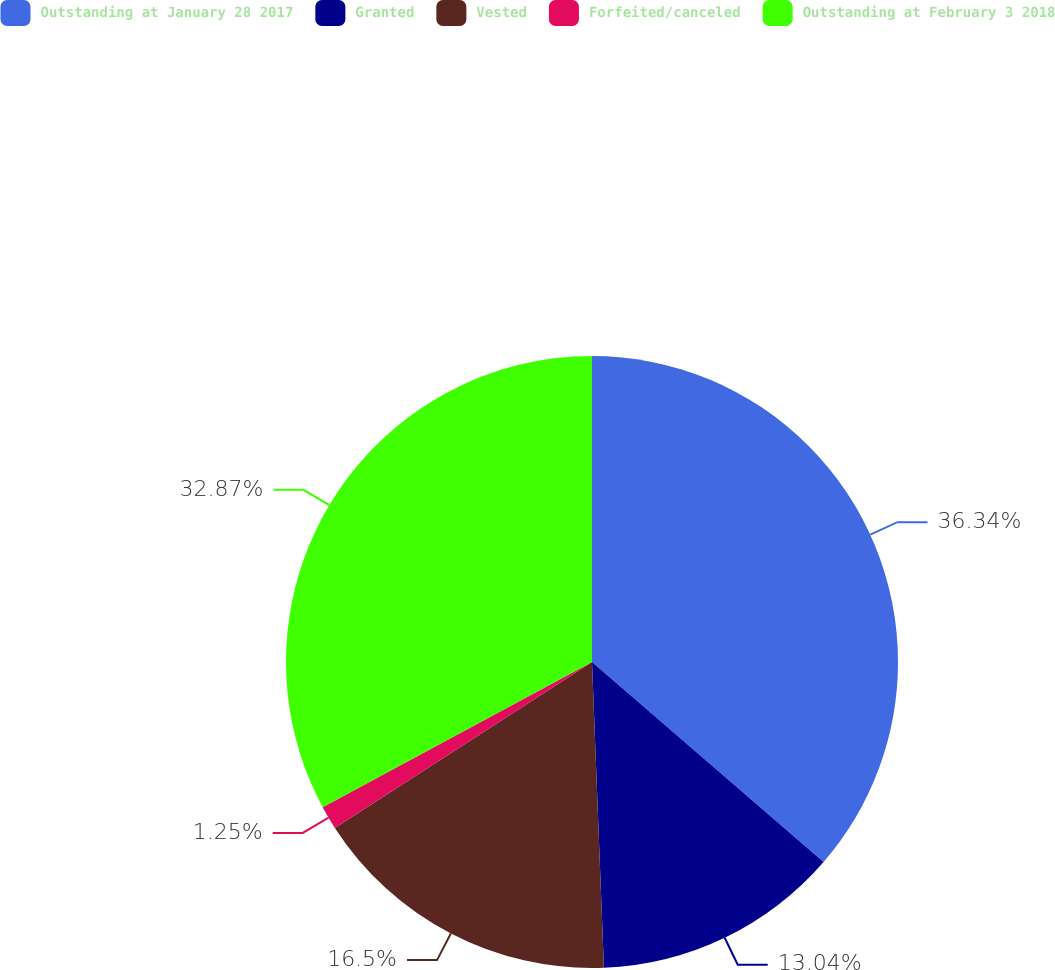Convert chart to OTSL. <chart><loc_0><loc_0><loc_500><loc_500><pie_chart><fcel>Outstanding at January 28 2017<fcel>Granted<fcel>Vested<fcel>Forfeited/canceled<fcel>Outstanding at February 3 2018<nl><fcel>36.34%<fcel>13.04%<fcel>16.5%<fcel>1.25%<fcel>32.87%<nl></chart> 